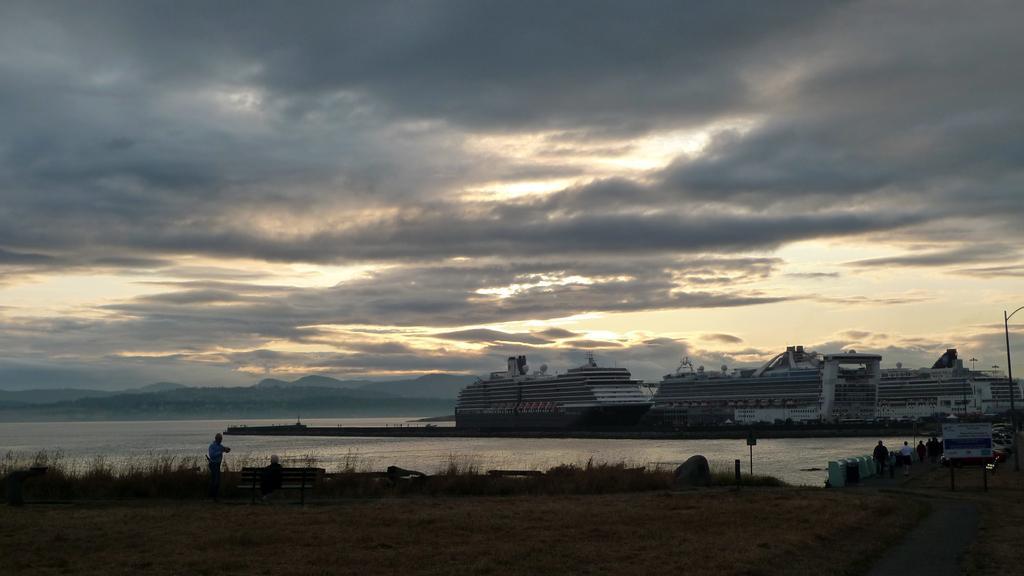How would you summarize this image in a sentence or two? In this image, we can see some water. We can see some ships. We can see a path above the water. There are a few people. We can see the ground. We can see some grass, a rock and some boards with text. There are a few vehicles. We can see a bench and a pole. We can see the sky with clouds. 